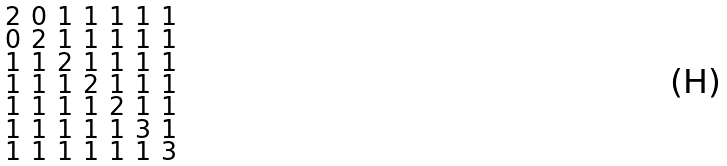<formula> <loc_0><loc_0><loc_500><loc_500>\begin{smallmatrix} 2 & 0 & 1 & 1 & 1 & 1 & 1 \\ 0 & 2 & 1 & 1 & 1 & 1 & 1 \\ 1 & 1 & 2 & 1 & 1 & 1 & 1 \\ 1 & 1 & 1 & 2 & 1 & 1 & 1 \\ 1 & 1 & 1 & 1 & 2 & 1 & 1 \\ 1 & 1 & 1 & 1 & 1 & 3 & 1 \\ 1 & 1 & 1 & 1 & 1 & 1 & 3 \end{smallmatrix}</formula> 